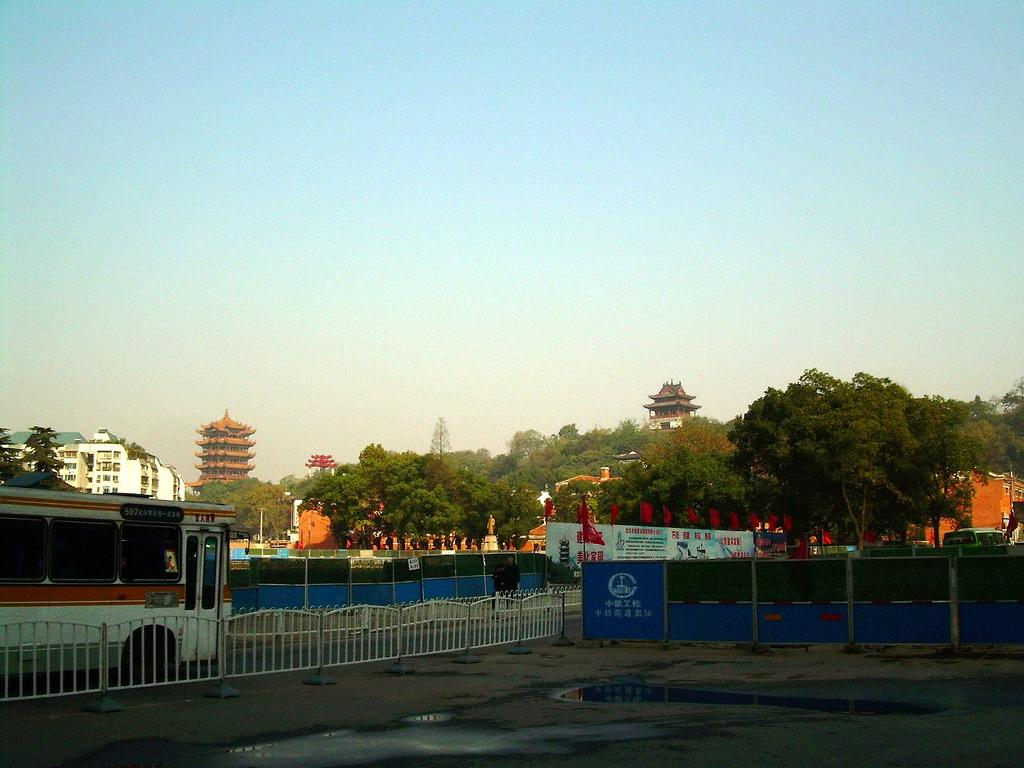What is the main subject of the image? There is a bus in the image. What can be seen near the bus? There is railing in the image. Are there any decorative elements in the image? Yes, there are flags and a banner in the image. What can be seen in the background of the image? There are trees, buildings, and the sky visible in the background of the image. What type of beetle can be seen crawling on the bus in the image? There is no beetle present on the bus in the image. Can you tell me how many rays are visible in the sky in the image? There are no rays visible in the sky in the image; only the sky is visible. 